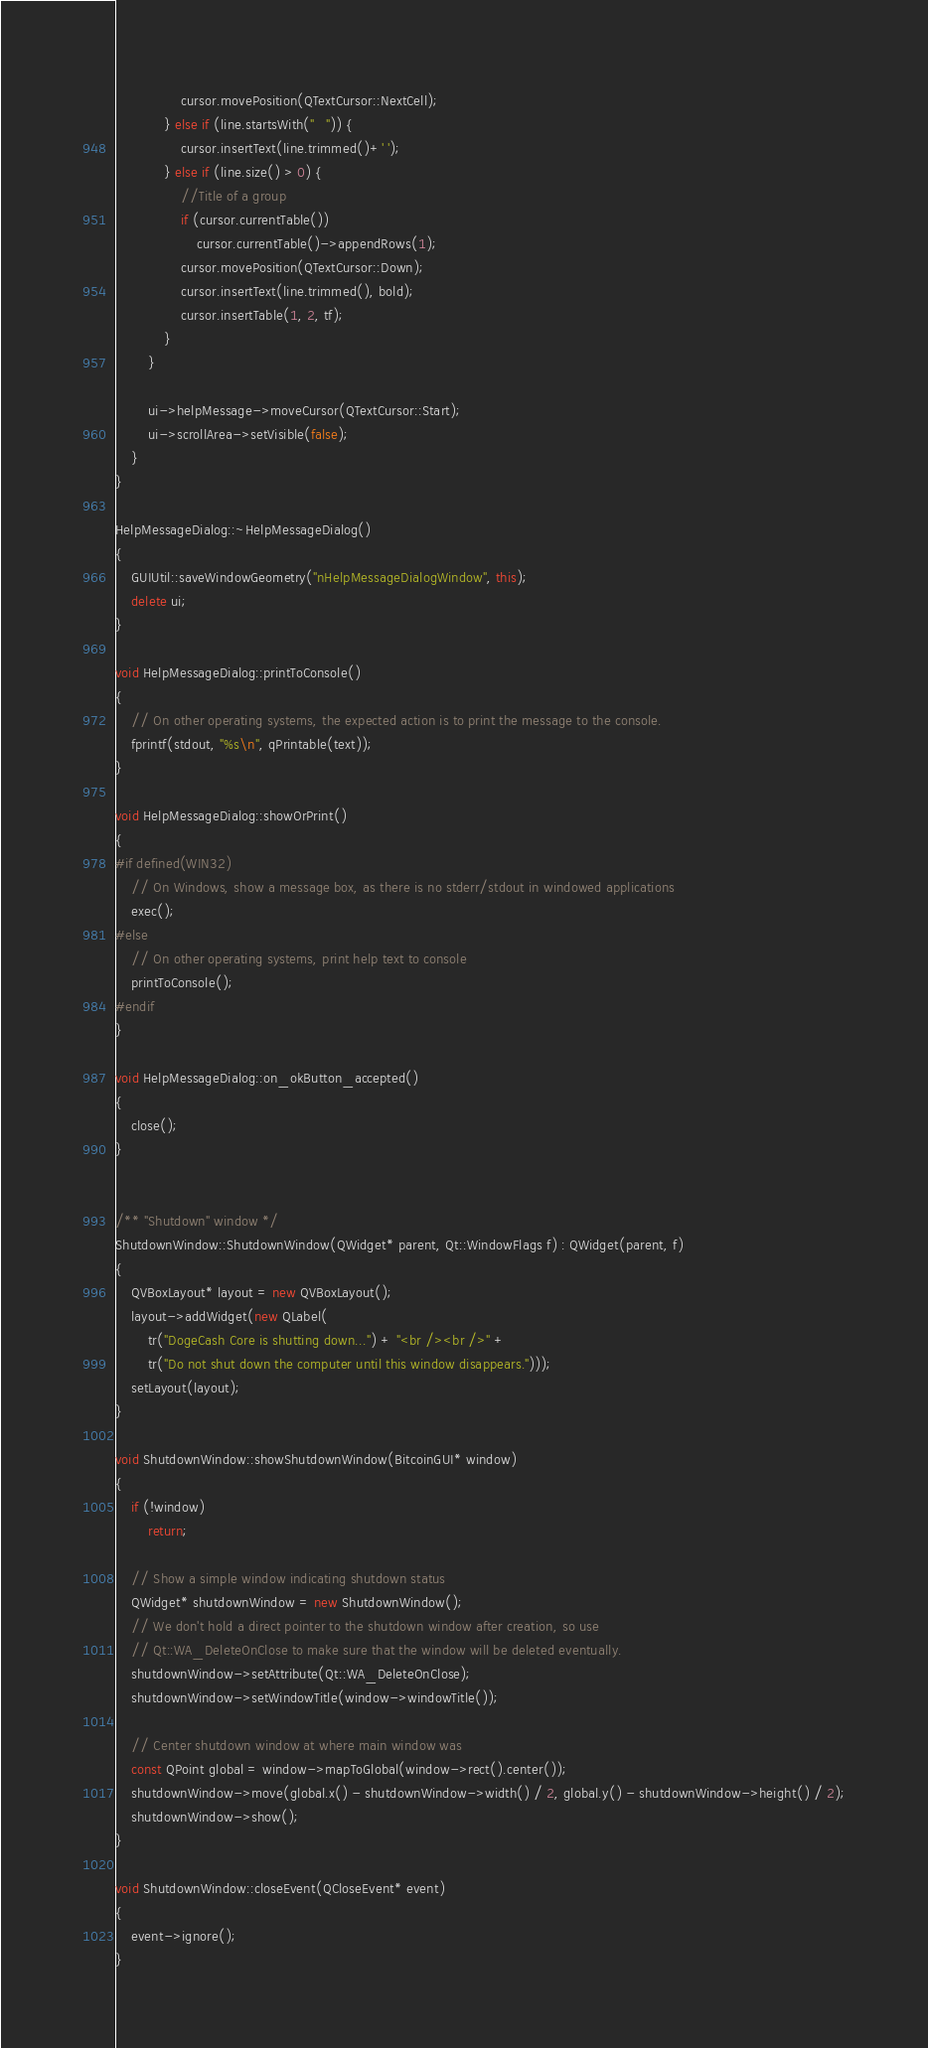Convert code to text. <code><loc_0><loc_0><loc_500><loc_500><_C++_>                cursor.movePosition(QTextCursor::NextCell);
            } else if (line.startsWith("   ")) {
                cursor.insertText(line.trimmed()+' ');
            } else if (line.size() > 0) {
                //Title of a group
                if (cursor.currentTable())
                    cursor.currentTable()->appendRows(1);
                cursor.movePosition(QTextCursor::Down);
                cursor.insertText(line.trimmed(), bold);
                cursor.insertTable(1, 2, tf);
            }
        }

        ui->helpMessage->moveCursor(QTextCursor::Start);
        ui->scrollArea->setVisible(false);
    }
}

HelpMessageDialog::~HelpMessageDialog()
{
    GUIUtil::saveWindowGeometry("nHelpMessageDialogWindow", this);
    delete ui;
}

void HelpMessageDialog::printToConsole()
{
    // On other operating systems, the expected action is to print the message to the console.
    fprintf(stdout, "%s\n", qPrintable(text));
}

void HelpMessageDialog::showOrPrint()
{
#if defined(WIN32)
    // On Windows, show a message box, as there is no stderr/stdout in windowed applications
    exec();
#else
    // On other operating systems, print help text to console
    printToConsole();
#endif
}

void HelpMessageDialog::on_okButton_accepted()
{
    close();
}


/** "Shutdown" window */
ShutdownWindow::ShutdownWindow(QWidget* parent, Qt::WindowFlags f) : QWidget(parent, f)
{
    QVBoxLayout* layout = new QVBoxLayout();
    layout->addWidget(new QLabel(
        tr("DogeCash Core is shutting down...") + "<br /><br />" +
        tr("Do not shut down the computer until this window disappears.")));
    setLayout(layout);
}

void ShutdownWindow::showShutdownWindow(BitcoinGUI* window)
{
    if (!window)
        return;

    // Show a simple window indicating shutdown status
    QWidget* shutdownWindow = new ShutdownWindow();
    // We don't hold a direct pointer to the shutdown window after creation, so use
    // Qt::WA_DeleteOnClose to make sure that the window will be deleted eventually.
    shutdownWindow->setAttribute(Qt::WA_DeleteOnClose);
    shutdownWindow->setWindowTitle(window->windowTitle());

    // Center shutdown window at where main window was
    const QPoint global = window->mapToGlobal(window->rect().center());
    shutdownWindow->move(global.x() - shutdownWindow->width() / 2, global.y() - shutdownWindow->height() / 2);
    shutdownWindow->show();
}

void ShutdownWindow::closeEvent(QCloseEvent* event)
{
    event->ignore();
}
</code> 